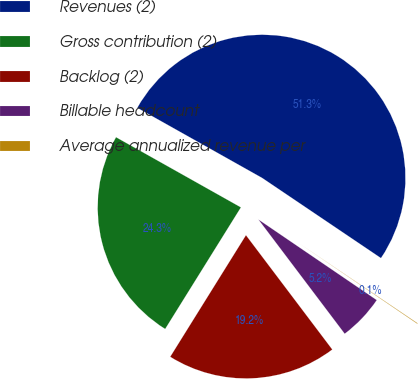<chart> <loc_0><loc_0><loc_500><loc_500><pie_chart><fcel>Revenues (2)<fcel>Gross contribution (2)<fcel>Backlog (2)<fcel>Billable headcount<fcel>Average annualized revenue per<nl><fcel>51.3%<fcel>24.28%<fcel>19.16%<fcel>5.19%<fcel>0.07%<nl></chart> 